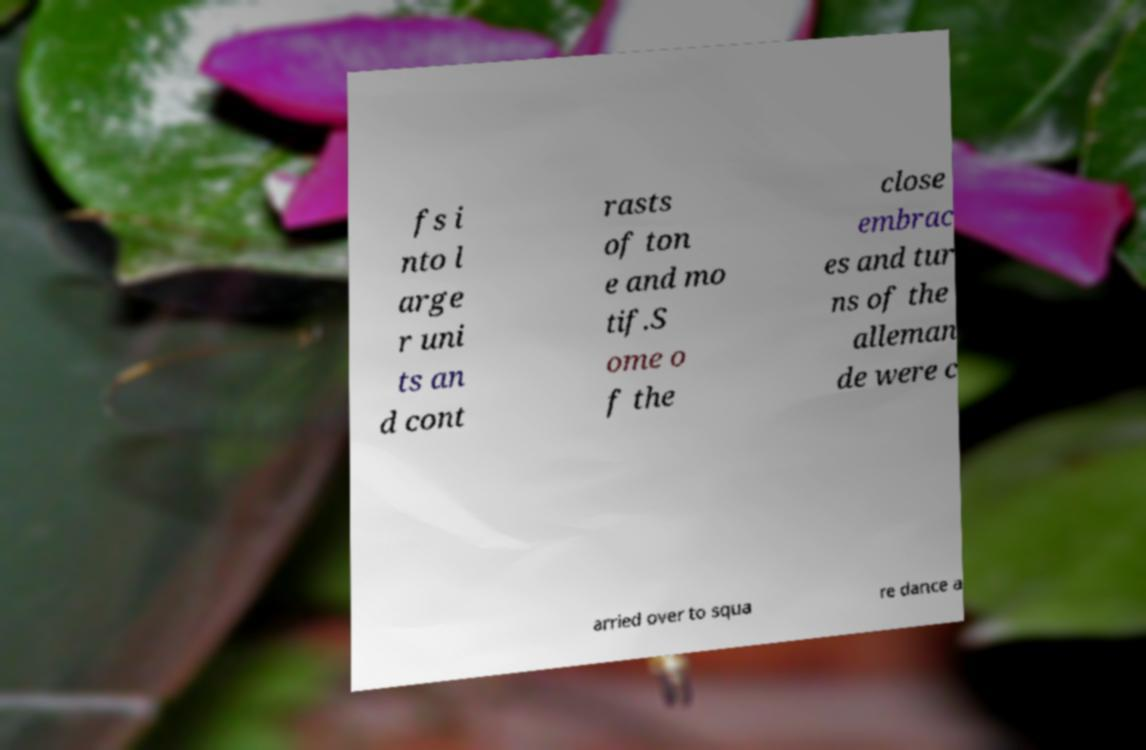For documentation purposes, I need the text within this image transcribed. Could you provide that? fs i nto l arge r uni ts an d cont rasts of ton e and mo tif.S ome o f the close embrac es and tur ns of the alleman de were c arried over to squa re dance a 